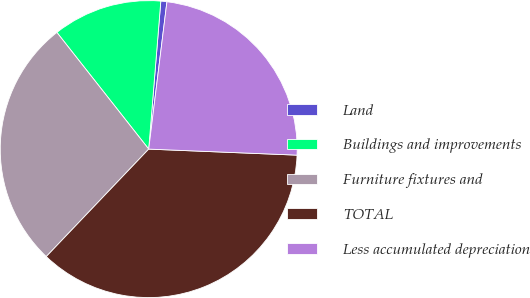<chart> <loc_0><loc_0><loc_500><loc_500><pie_chart><fcel>Land<fcel>Buildings and improvements<fcel>Furniture fixtures and<fcel>TOTAL<fcel>Less accumulated depreciation<nl><fcel>0.66%<fcel>11.91%<fcel>27.27%<fcel>36.47%<fcel>23.69%<nl></chart> 